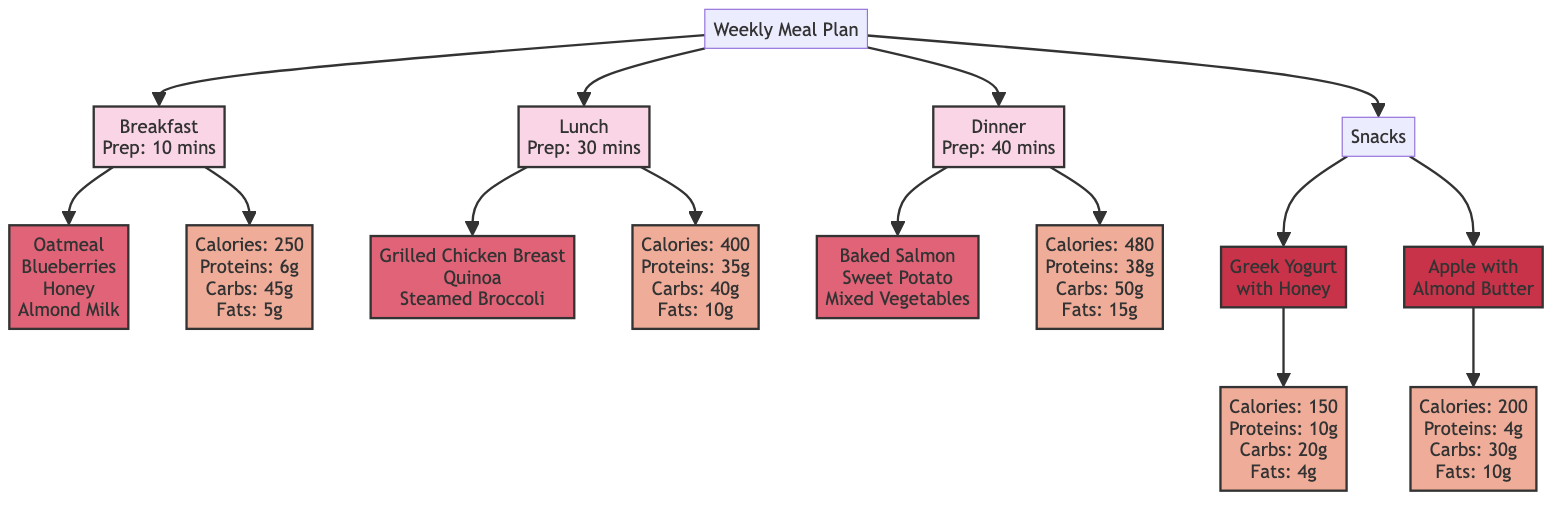What are the ingredients for breakfast? The breakfast block points to another block that lists the ingredients: Oatmeal, Blueberries, Honey, and Almond Milk.
Answer: Oatmeal, Blueberries, Honey, Almond Milk What is the preparation time for lunch? The lunch block directly shows the preparation time stated as 30 minutes.
Answer: 30 minutes How many meals are listed in the meal plan? The main Weekly Meal Plan block branches out to four distinct meal categories: Breakfast, Lunch, Dinner, and Snacks, making a total of four meals.
Answer: 4 What are the nutritional values for dinner? Dinner block provides the nutritional information, which is: Calories: 480, Proteins: 38g, Carbs: 50g, Fats: 15g.
Answer: Calories: 480, Proteins: 38g, Carbs: 50g, Fats: 15g Which snack has the highest calorie count? By comparing the nutritional values of the two snacks presented in the diagram, Greek Yogurt with Honey has 150 calories and Apple with Almond Butter has 200 calories; thus, Apple with Almond Butter has the highest caloric value.
Answer: Apple with Almond Butter What is the relationship between lunch and its ingredients? The lunch block is connected to its ingredients block, indicating that the ingredients listed are specifically for the lunch meal, which includes Grilled Chicken Breast, Quinoa, and Steamed Broccoli.
Answer: Grilled Chicken Breast, Quinoa, Steamed Broccoli What is the total preparation time for all meals? The preparation times for Breakfast (10 mins), Lunch (30 mins), and Dinner (40 mins) can be summed up: 10 + 30 + 40 = 80 minutes. The snacks have separate prep times of 5 minutes each, adding another 10 minutes (5 mins x 2). Total calculation: 80 + 10 = 90 minutes.
Answer: 90 minutes What is the main nutrient content of Greek Yogurt with Honey? The nutritional value block for this snack specifies its nutrients: Calories: 150, Proteins: 10g, Carbs: 20g, Fats: 4g.
Answer: Calories: 150, Proteins: 10g, Carbs: 20g, Fats: 4g 